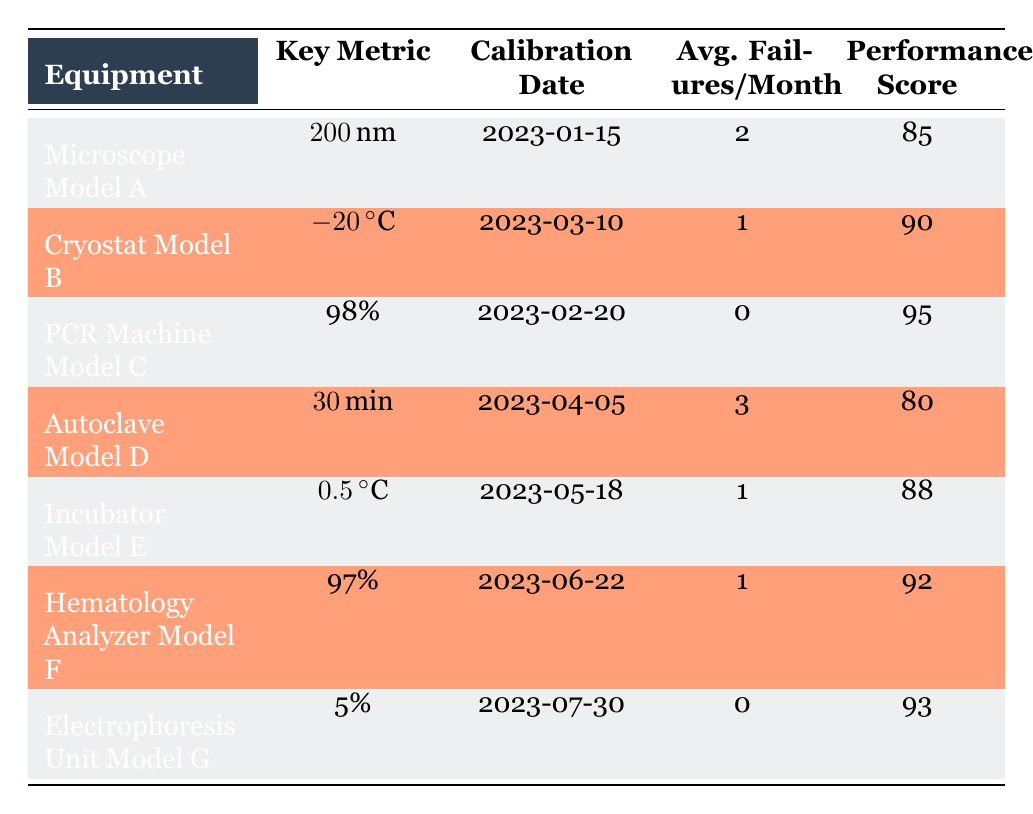What is the performance score of the Cryostat Model B? The performance score for Cryostat Model B is listed in the table under the "Performance Score" column, which shows 90.
Answer: 90 Which equipment had the highest average failures per month? By checking the "Avg. Failures/Month" column, Autoclave Model D had the highest value, which is 3.
Answer: Autoclave Model D Is the calibration date for the PCR Machine Model C earlier than that of the Incubator Model E? The calibration date for PCR Machine Model C is 2023-02-20, while Incubator Model E is 2023-05-18. Since February is earlier than May, the statement is true.
Answer: Yes What is the difference in performance scores between the Microscope Model A and the PCR Machine Model C? The performance score for Microscope Model A is 85 and for PCR Machine Model C is 95. The difference is calculated as 95 - 85 = 10.
Answer: 10 What is the average temperature accuracy of the Cryostat Model B and Incubator Model E combined? The temperature accuracy for Cryostat Model B is -20°C, and for Incubator Model E is 0.5°C. To find the average, first convert -20 and 0.5 to a common denominator: (-20 + 0.5) / 2 = -19.75°C.
Answer: -19.75°C Has any equipment reported zero average failures per month? Looking at the "Avg. Failures/Month" column, both PCR Machine Model C and Electrophoresis Unit Model G show 0, confirming that they reported zero failures.
Answer: Yes Which equipment has the longest calibration interval based on the dates provided? To assess the calibration intervals, we compute the days between the calibration date of each equipment listed in the table. The longest interval is from the earliest (Microscope Model A on 2023-01-15) to the latest (Electrophoresis Unit Model G on 2023-07-30), which is roughly 6.5 months.
Answer: Microscope Model A What is the maximum cycle consistency percentage among the listed equipment? The highest cycle consistency percentage is found under PCR Machine Model C, listed at 98%. This is the maximum value in the table.
Answer: 98% Is the average failure rate across all the equipment more than 1? To determine this, we sum the average failures for all equipment: 2 + 1 + 0 + 3 + 1 + 1 + 0 = 8. Then divide by the number of equipment (7), yielding an average of approximately 1.14, which is more than 1.
Answer: Yes 